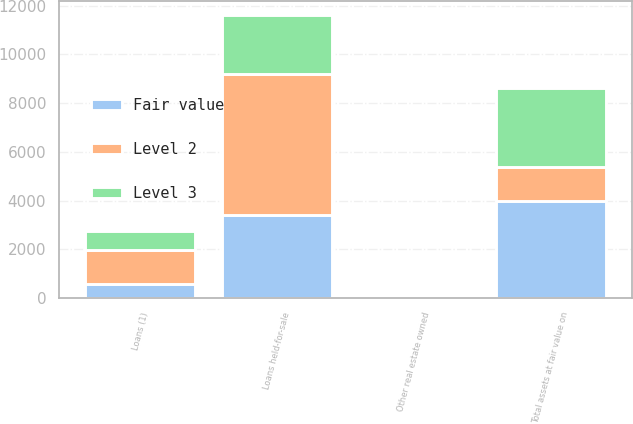Convert chart to OTSL. <chart><loc_0><loc_0><loc_500><loc_500><stacked_bar_chart><ecel><fcel>Loans held-for-sale<fcel>Other real estate owned<fcel>Loans (1)<fcel>Total assets at fair value on<nl><fcel>Level 2<fcel>5802<fcel>75<fcel>1376<fcel>1376<nl><fcel>Fair value<fcel>3389<fcel>15<fcel>586<fcel>3990<nl><fcel>Level 3<fcel>2413<fcel>60<fcel>790<fcel>3263<nl></chart> 